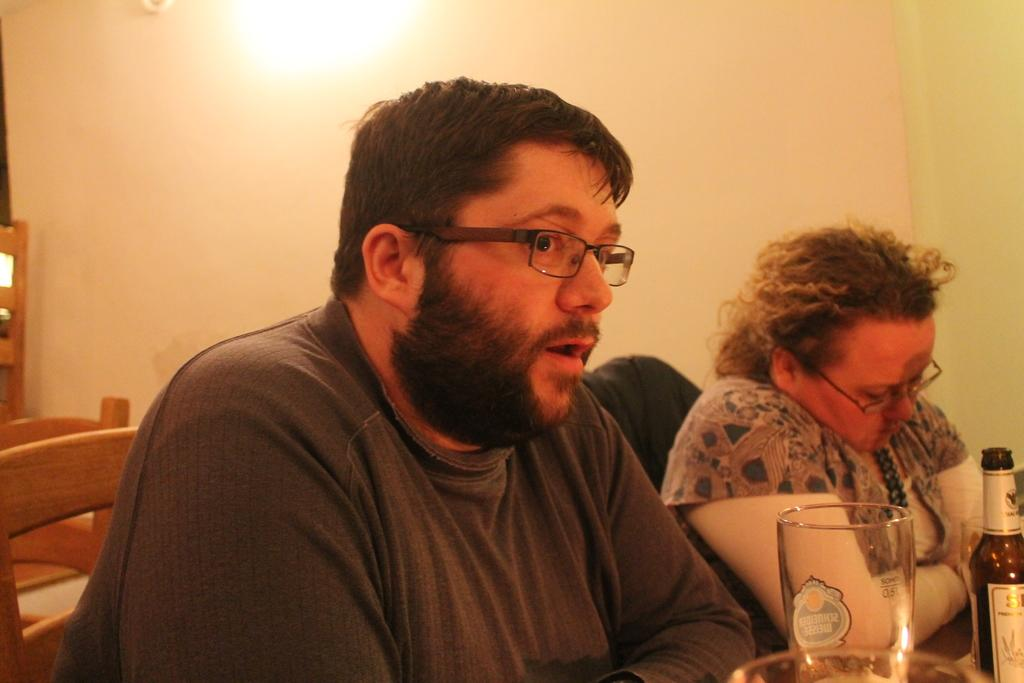How many people are sitting in the image? There are two people sitting in the image. What are the people sitting on? The people are sitting on chairs. What can be seen on the table in the image? There is a glass and a wine bottle on the table. What is visible in the background of the image? There is a wall in the image. What type of organization is responsible for the twist in the image? There is no twist present in the image, so it is not possible to determine which organization might be responsible. 